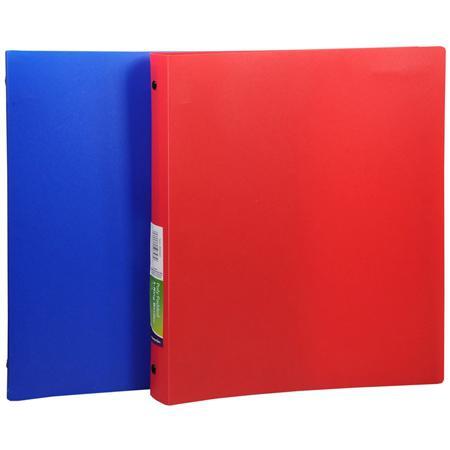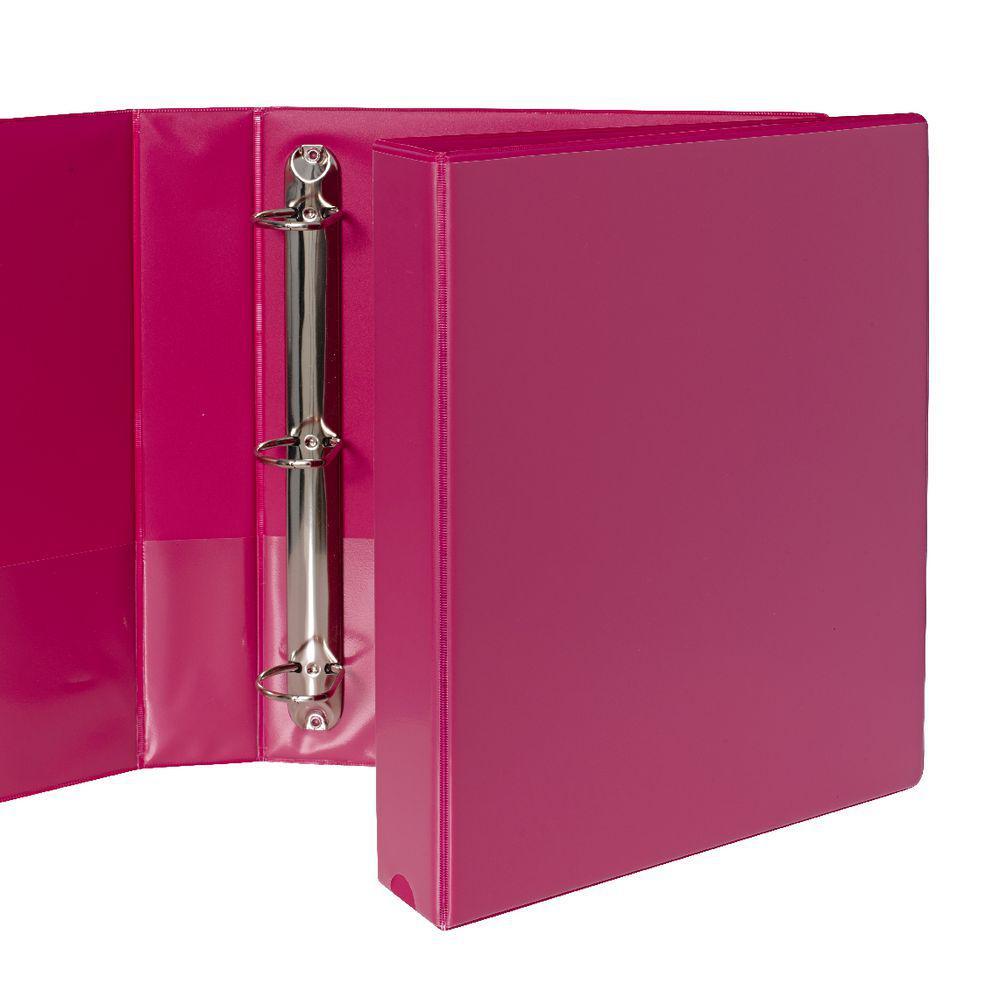The first image is the image on the left, the second image is the image on the right. Evaluate the accuracy of this statement regarding the images: "The left image contains at least two binders.". Is it true? Answer yes or no. Yes. The first image is the image on the left, the second image is the image on the right. Evaluate the accuracy of this statement regarding the images: "There are fewer than four binders in total.". Is it true? Answer yes or no. No. 